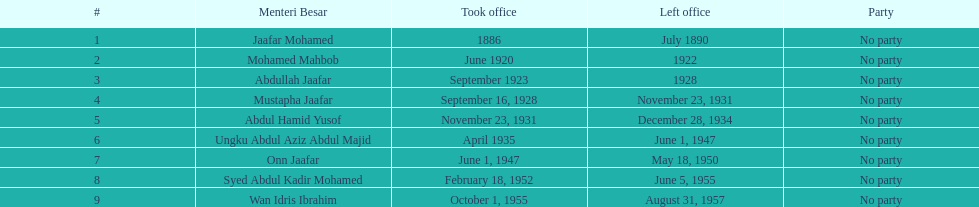Who assumed office following onn jaafar? Syed Abdul Kadir Mohamed. 